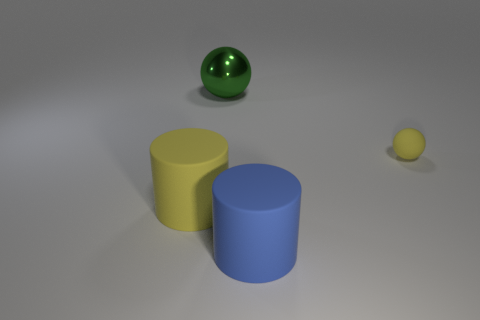Subtract 2 cylinders. How many cylinders are left? 0 Add 4 metallic balls. How many objects exist? 8 Subtract all yellow spheres. How many spheres are left? 1 Subtract all brown cylinders. How many gray balls are left? 0 Subtract 0 purple spheres. How many objects are left? 4 Subtract all brown balls. Subtract all brown cylinders. How many balls are left? 2 Subtract all big matte cylinders. Subtract all rubber cylinders. How many objects are left? 0 Add 4 tiny spheres. How many tiny spheres are left? 5 Add 1 small blue objects. How many small blue objects exist? 1 